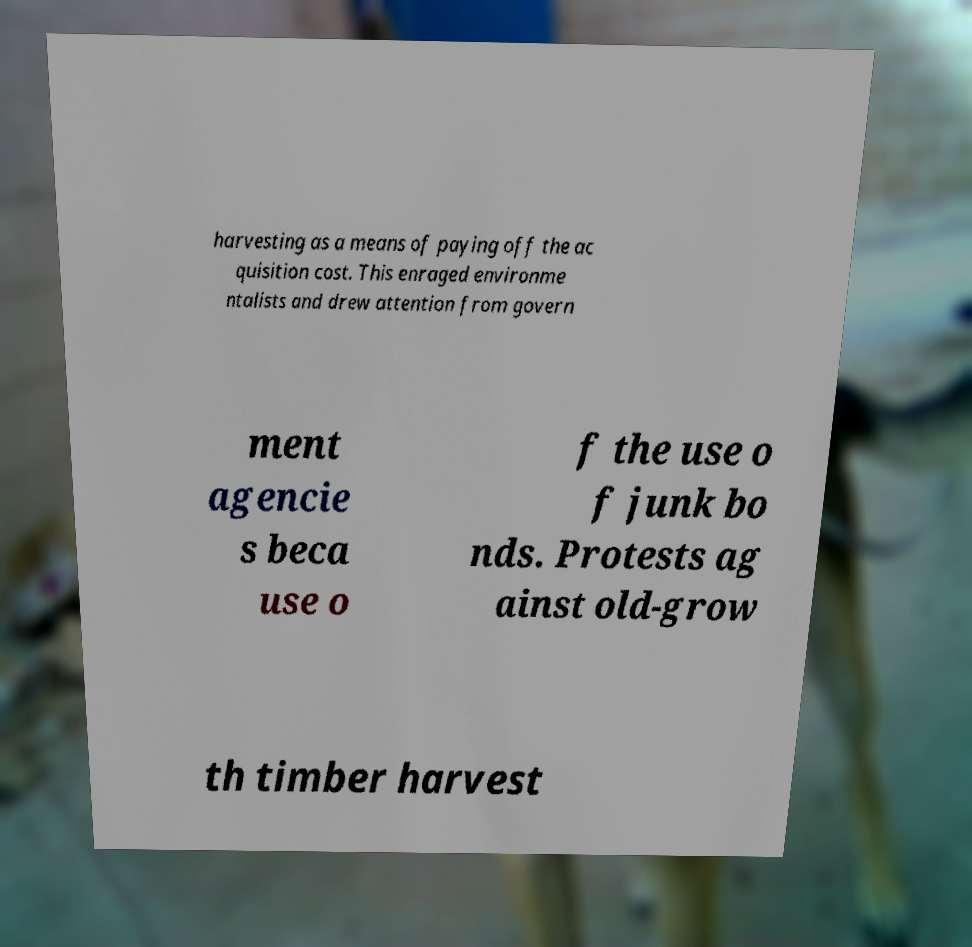Please identify and transcribe the text found in this image. harvesting as a means of paying off the ac quisition cost. This enraged environme ntalists and drew attention from govern ment agencie s beca use o f the use o f junk bo nds. Protests ag ainst old-grow th timber harvest 